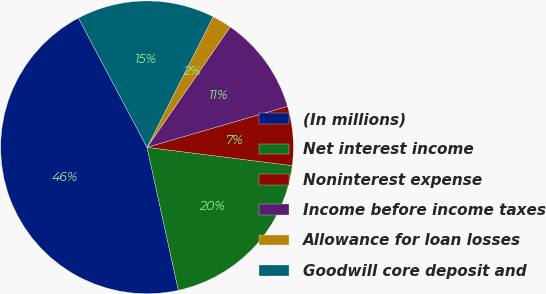Convert chart to OTSL. <chart><loc_0><loc_0><loc_500><loc_500><pie_chart><fcel>(In millions)<fcel>Net interest income<fcel>Noninterest expense<fcel>Income before income taxes<fcel>Allowance for loan losses<fcel>Goodwill core deposit and<nl><fcel>45.67%<fcel>19.57%<fcel>6.51%<fcel>10.87%<fcel>2.16%<fcel>15.22%<nl></chart> 